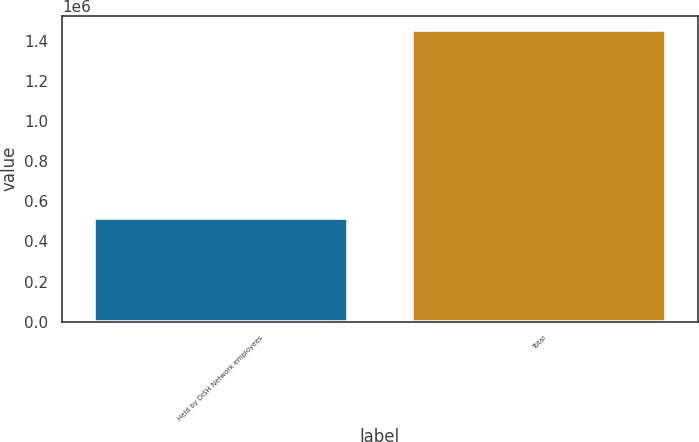Convert chart. <chart><loc_0><loc_0><loc_500><loc_500><bar_chart><fcel>Held by DISH Network employees<fcel>Total<nl><fcel>517735<fcel>1.45273e+06<nl></chart> 